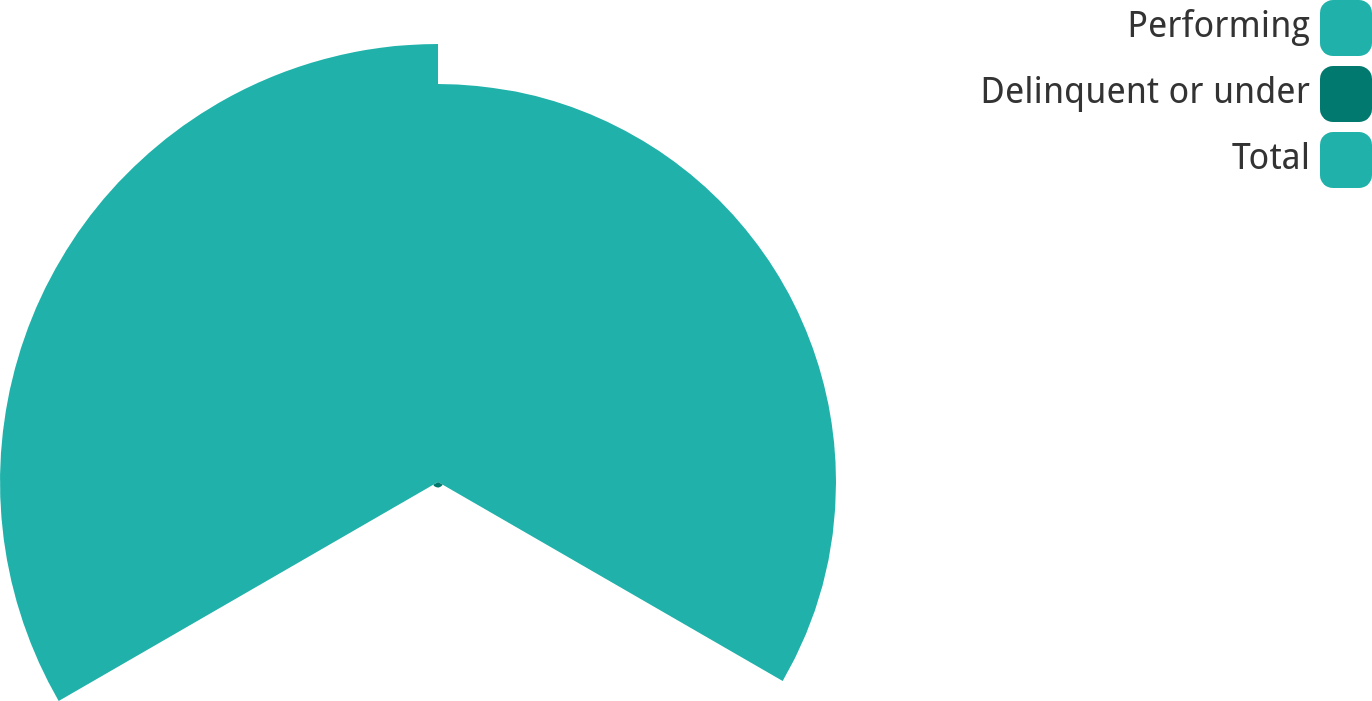<chart> <loc_0><loc_0><loc_500><loc_500><pie_chart><fcel>Performing<fcel>Delinquent or under<fcel>Total<nl><fcel>47.3%<fcel>0.65%<fcel>52.05%<nl></chart> 